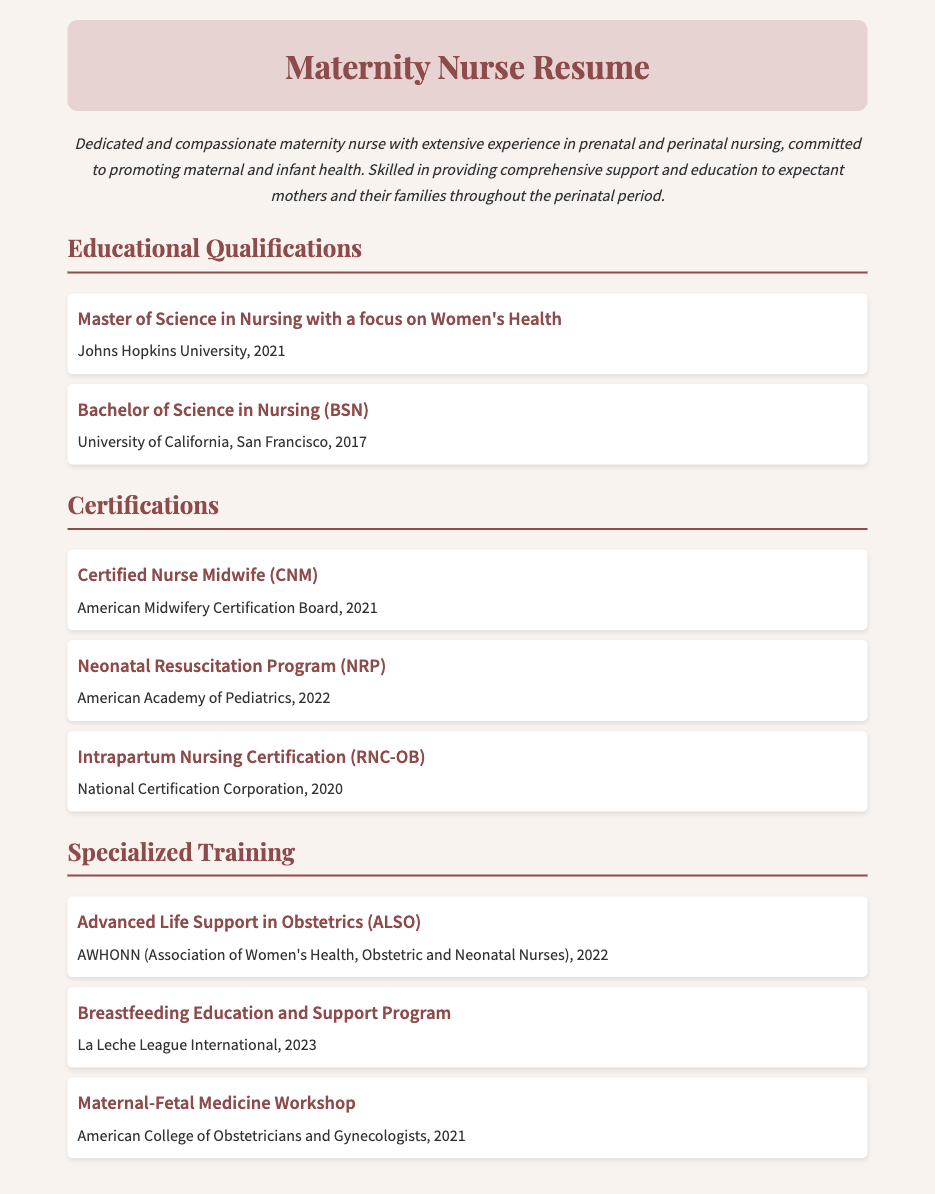What is the highest degree obtained? The highest degree listed in the educational qualifications is the Master's degree in Nursing.
Answer: Master of Science in Nursing with a focus on Women's Health Where did the nursing certifications come from? The nursing certifications are awarded by various boards and organizations, as indicated in the document.
Answer: American Midwifery Certification Board, American Academy of Pediatrics, National Certification Corporation In what year did the individual graduate with their BSN? The document states the year of graduation for the BSN, which is 2017.
Answer: 2017 What specialized training was completed in 2022? The document lists specialized training programs completed in 2022.
Answer: Advanced Life Support in Obstetrics (ALSO), Neonatal Resuscitation Program (NRP) How many certifications are listed in the document? The document lists a total number of certifications under the Certifications section.
Answer: Three What is the main focus of the Master’s program? The document describes the main focus of the Master’s program in Nursing.
Answer: Women's Health Which organization provided the training for breastfeeding education? The organization responsible for providing this training is indicated in the document.
Answer: La Leche League International What nursing role is associated with the abbreviation CNM? The document specifies what the certification with the abbreviation CNM stands for.
Answer: Certified Nurse Midwife 